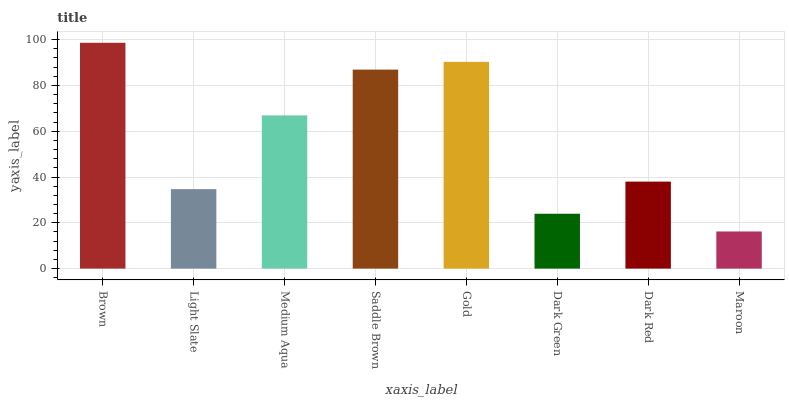Is Light Slate the minimum?
Answer yes or no. No. Is Light Slate the maximum?
Answer yes or no. No. Is Brown greater than Light Slate?
Answer yes or no. Yes. Is Light Slate less than Brown?
Answer yes or no. Yes. Is Light Slate greater than Brown?
Answer yes or no. No. Is Brown less than Light Slate?
Answer yes or no. No. Is Medium Aqua the high median?
Answer yes or no. Yes. Is Dark Red the low median?
Answer yes or no. Yes. Is Light Slate the high median?
Answer yes or no. No. Is Dark Green the low median?
Answer yes or no. No. 